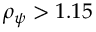<formula> <loc_0><loc_0><loc_500><loc_500>\rho _ { \psi } > 1 . 1 5</formula> 